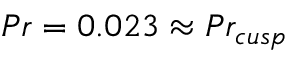Convert formula to latex. <formula><loc_0><loc_0><loc_500><loc_500>P r = 0 . 0 2 3 \approx P r _ { c u s p }</formula> 